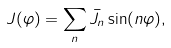<formula> <loc_0><loc_0><loc_500><loc_500>J ( \varphi ) = \sum _ { n } \bar { J } _ { n } \sin ( n \varphi ) ,</formula> 